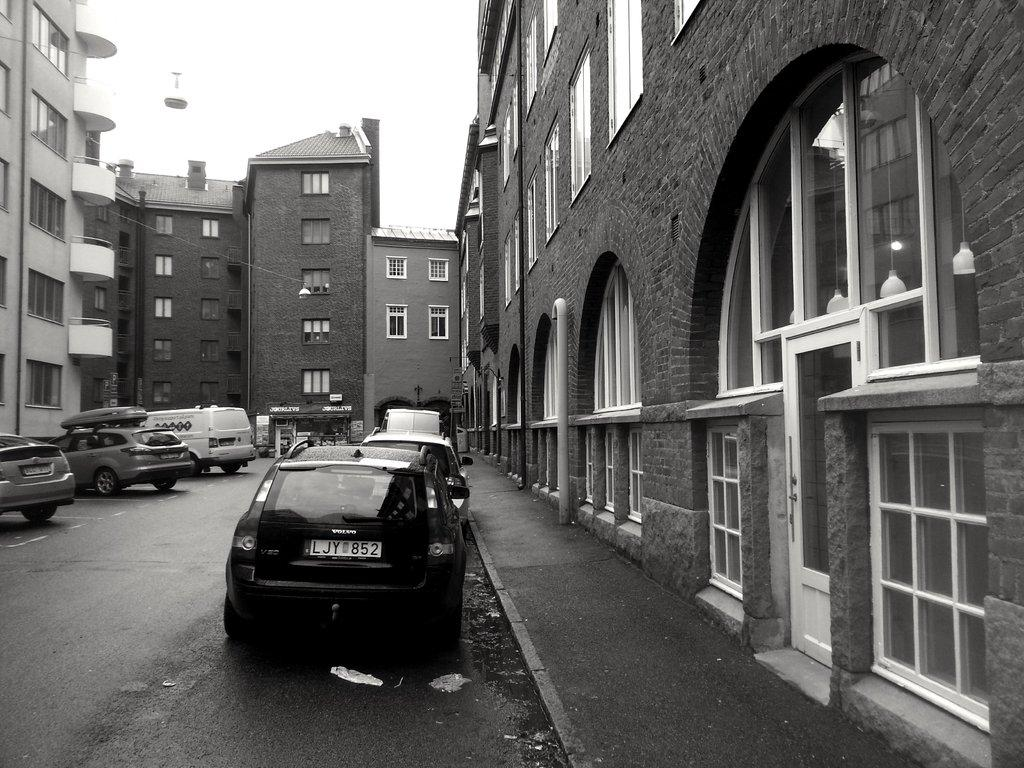What can be seen on the road in the image? There are vehicles on the road in the image. What feature do the buildings in the image have? The buildings in the image have windows. What part of the natural environment is visible in the image? The sky is visible in the background of the image. Can you tell me how many insects are crawling on the governor in the image? There is no governor or insects present in the image. Is there a stream visible in the image? There is no stream visible in the image; only vehicles, buildings, and the sky are present. 